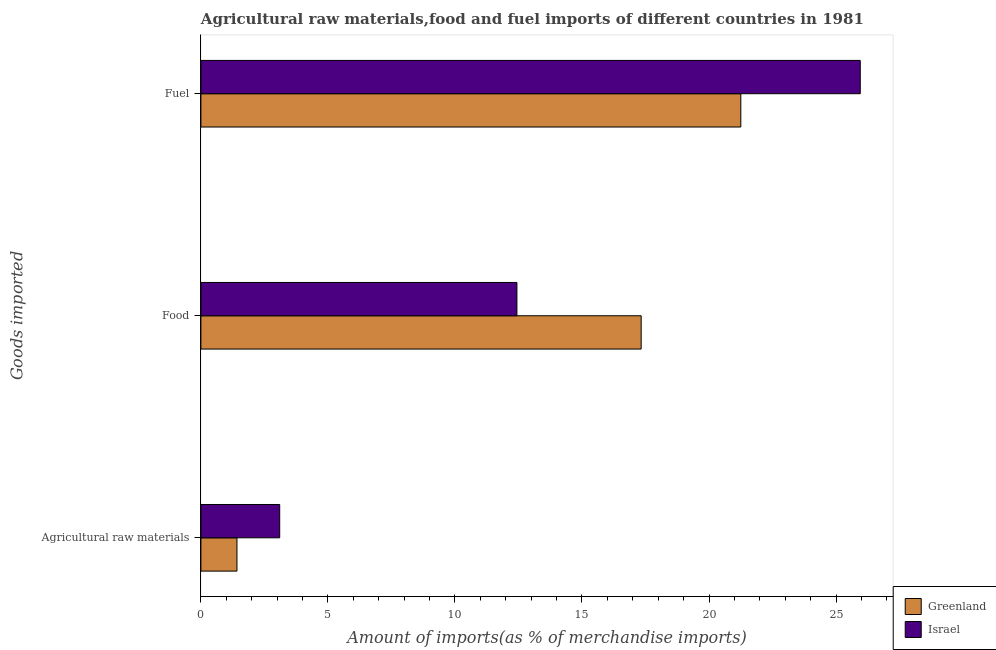How many different coloured bars are there?
Offer a terse response. 2. Are the number of bars on each tick of the Y-axis equal?
Give a very brief answer. Yes. How many bars are there on the 2nd tick from the top?
Offer a very short reply. 2. What is the label of the 3rd group of bars from the top?
Ensure brevity in your answer.  Agricultural raw materials. What is the percentage of fuel imports in Israel?
Give a very brief answer. 25.95. Across all countries, what is the maximum percentage of fuel imports?
Offer a terse response. 25.95. Across all countries, what is the minimum percentage of raw materials imports?
Offer a terse response. 1.42. In which country was the percentage of fuel imports minimum?
Make the answer very short. Greenland. What is the total percentage of food imports in the graph?
Make the answer very short. 29.77. What is the difference between the percentage of raw materials imports in Greenland and that in Israel?
Ensure brevity in your answer.  -1.68. What is the difference between the percentage of fuel imports in Greenland and the percentage of food imports in Israel?
Your answer should be compact. 8.81. What is the average percentage of food imports per country?
Provide a short and direct response. 14.88. What is the difference between the percentage of food imports and percentage of fuel imports in Israel?
Provide a succinct answer. -13.51. What is the ratio of the percentage of food imports in Greenland to that in Israel?
Provide a short and direct response. 1.39. Is the difference between the percentage of fuel imports in Greenland and Israel greater than the difference between the percentage of raw materials imports in Greenland and Israel?
Ensure brevity in your answer.  No. What is the difference between the highest and the second highest percentage of raw materials imports?
Your answer should be very brief. 1.68. What is the difference between the highest and the lowest percentage of raw materials imports?
Ensure brevity in your answer.  1.68. Is the sum of the percentage of raw materials imports in Israel and Greenland greater than the maximum percentage of food imports across all countries?
Offer a very short reply. No. What does the 2nd bar from the top in Agricultural raw materials represents?
Offer a terse response. Greenland. What does the 1st bar from the bottom in Agricultural raw materials represents?
Your answer should be compact. Greenland. Is it the case that in every country, the sum of the percentage of raw materials imports and percentage of food imports is greater than the percentage of fuel imports?
Offer a terse response. No. How many bars are there?
Your answer should be very brief. 6. Are all the bars in the graph horizontal?
Keep it short and to the point. Yes. Are the values on the major ticks of X-axis written in scientific E-notation?
Offer a very short reply. No. Does the graph contain any zero values?
Your answer should be very brief. No. Does the graph contain grids?
Give a very brief answer. No. How are the legend labels stacked?
Your answer should be very brief. Vertical. What is the title of the graph?
Your response must be concise. Agricultural raw materials,food and fuel imports of different countries in 1981. What is the label or title of the X-axis?
Your answer should be compact. Amount of imports(as % of merchandise imports). What is the label or title of the Y-axis?
Provide a short and direct response. Goods imported. What is the Amount of imports(as % of merchandise imports) in Greenland in Agricultural raw materials?
Your response must be concise. 1.42. What is the Amount of imports(as % of merchandise imports) of Israel in Agricultural raw materials?
Your answer should be compact. 3.1. What is the Amount of imports(as % of merchandise imports) of Greenland in Food?
Your response must be concise. 17.33. What is the Amount of imports(as % of merchandise imports) in Israel in Food?
Ensure brevity in your answer.  12.44. What is the Amount of imports(as % of merchandise imports) of Greenland in Fuel?
Your answer should be very brief. 21.25. What is the Amount of imports(as % of merchandise imports) in Israel in Fuel?
Your answer should be compact. 25.95. Across all Goods imported, what is the maximum Amount of imports(as % of merchandise imports) in Greenland?
Give a very brief answer. 21.25. Across all Goods imported, what is the maximum Amount of imports(as % of merchandise imports) in Israel?
Offer a terse response. 25.95. Across all Goods imported, what is the minimum Amount of imports(as % of merchandise imports) of Greenland?
Provide a short and direct response. 1.42. Across all Goods imported, what is the minimum Amount of imports(as % of merchandise imports) of Israel?
Your answer should be compact. 3.1. What is the total Amount of imports(as % of merchandise imports) in Greenland in the graph?
Provide a succinct answer. 40. What is the total Amount of imports(as % of merchandise imports) of Israel in the graph?
Provide a succinct answer. 41.49. What is the difference between the Amount of imports(as % of merchandise imports) of Greenland in Agricultural raw materials and that in Food?
Make the answer very short. -15.91. What is the difference between the Amount of imports(as % of merchandise imports) of Israel in Agricultural raw materials and that in Food?
Make the answer very short. -9.34. What is the difference between the Amount of imports(as % of merchandise imports) of Greenland in Agricultural raw materials and that in Fuel?
Give a very brief answer. -19.83. What is the difference between the Amount of imports(as % of merchandise imports) in Israel in Agricultural raw materials and that in Fuel?
Give a very brief answer. -22.85. What is the difference between the Amount of imports(as % of merchandise imports) in Greenland in Food and that in Fuel?
Make the answer very short. -3.92. What is the difference between the Amount of imports(as % of merchandise imports) of Israel in Food and that in Fuel?
Keep it short and to the point. -13.51. What is the difference between the Amount of imports(as % of merchandise imports) of Greenland in Agricultural raw materials and the Amount of imports(as % of merchandise imports) of Israel in Food?
Make the answer very short. -11.02. What is the difference between the Amount of imports(as % of merchandise imports) in Greenland in Agricultural raw materials and the Amount of imports(as % of merchandise imports) in Israel in Fuel?
Ensure brevity in your answer.  -24.53. What is the difference between the Amount of imports(as % of merchandise imports) of Greenland in Food and the Amount of imports(as % of merchandise imports) of Israel in Fuel?
Provide a short and direct response. -8.62. What is the average Amount of imports(as % of merchandise imports) of Greenland per Goods imported?
Give a very brief answer. 13.33. What is the average Amount of imports(as % of merchandise imports) in Israel per Goods imported?
Provide a short and direct response. 13.83. What is the difference between the Amount of imports(as % of merchandise imports) in Greenland and Amount of imports(as % of merchandise imports) in Israel in Agricultural raw materials?
Offer a terse response. -1.68. What is the difference between the Amount of imports(as % of merchandise imports) of Greenland and Amount of imports(as % of merchandise imports) of Israel in Food?
Your answer should be compact. 4.89. What is the difference between the Amount of imports(as % of merchandise imports) of Greenland and Amount of imports(as % of merchandise imports) of Israel in Fuel?
Your answer should be very brief. -4.7. What is the ratio of the Amount of imports(as % of merchandise imports) in Greenland in Agricultural raw materials to that in Food?
Offer a very short reply. 0.08. What is the ratio of the Amount of imports(as % of merchandise imports) in Israel in Agricultural raw materials to that in Food?
Offer a terse response. 0.25. What is the ratio of the Amount of imports(as % of merchandise imports) in Greenland in Agricultural raw materials to that in Fuel?
Make the answer very short. 0.07. What is the ratio of the Amount of imports(as % of merchandise imports) of Israel in Agricultural raw materials to that in Fuel?
Keep it short and to the point. 0.12. What is the ratio of the Amount of imports(as % of merchandise imports) in Greenland in Food to that in Fuel?
Keep it short and to the point. 0.82. What is the ratio of the Amount of imports(as % of merchandise imports) in Israel in Food to that in Fuel?
Make the answer very short. 0.48. What is the difference between the highest and the second highest Amount of imports(as % of merchandise imports) of Greenland?
Keep it short and to the point. 3.92. What is the difference between the highest and the second highest Amount of imports(as % of merchandise imports) of Israel?
Keep it short and to the point. 13.51. What is the difference between the highest and the lowest Amount of imports(as % of merchandise imports) in Greenland?
Keep it short and to the point. 19.83. What is the difference between the highest and the lowest Amount of imports(as % of merchandise imports) in Israel?
Make the answer very short. 22.85. 